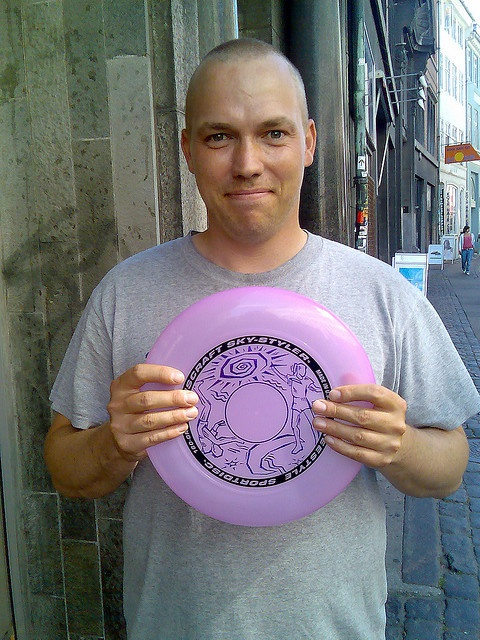Describe the objects in this image and their specific colors. I can see people in gray, darkgray, lavender, and violet tones, frisbee in gray and violet tones, and people in gray, navy, blue, purple, and darkgray tones in this image. 